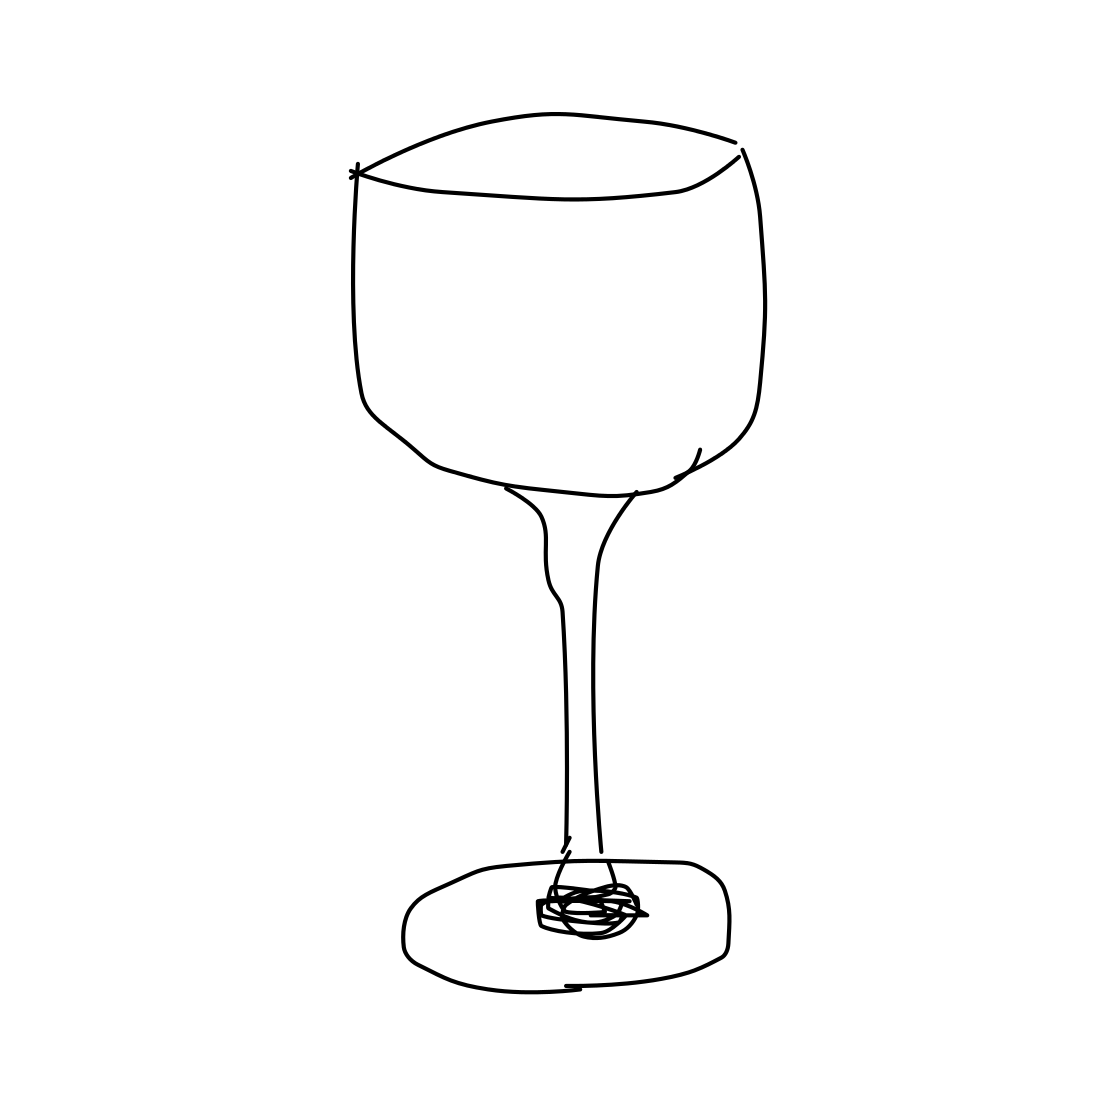Can you tell if the wineglass is full or empty? In the drawing, the wineglass appears to be empty. There are no indications, such as level lines or color differences, that suggest the presence of any liquid in the bowl of the glass. 